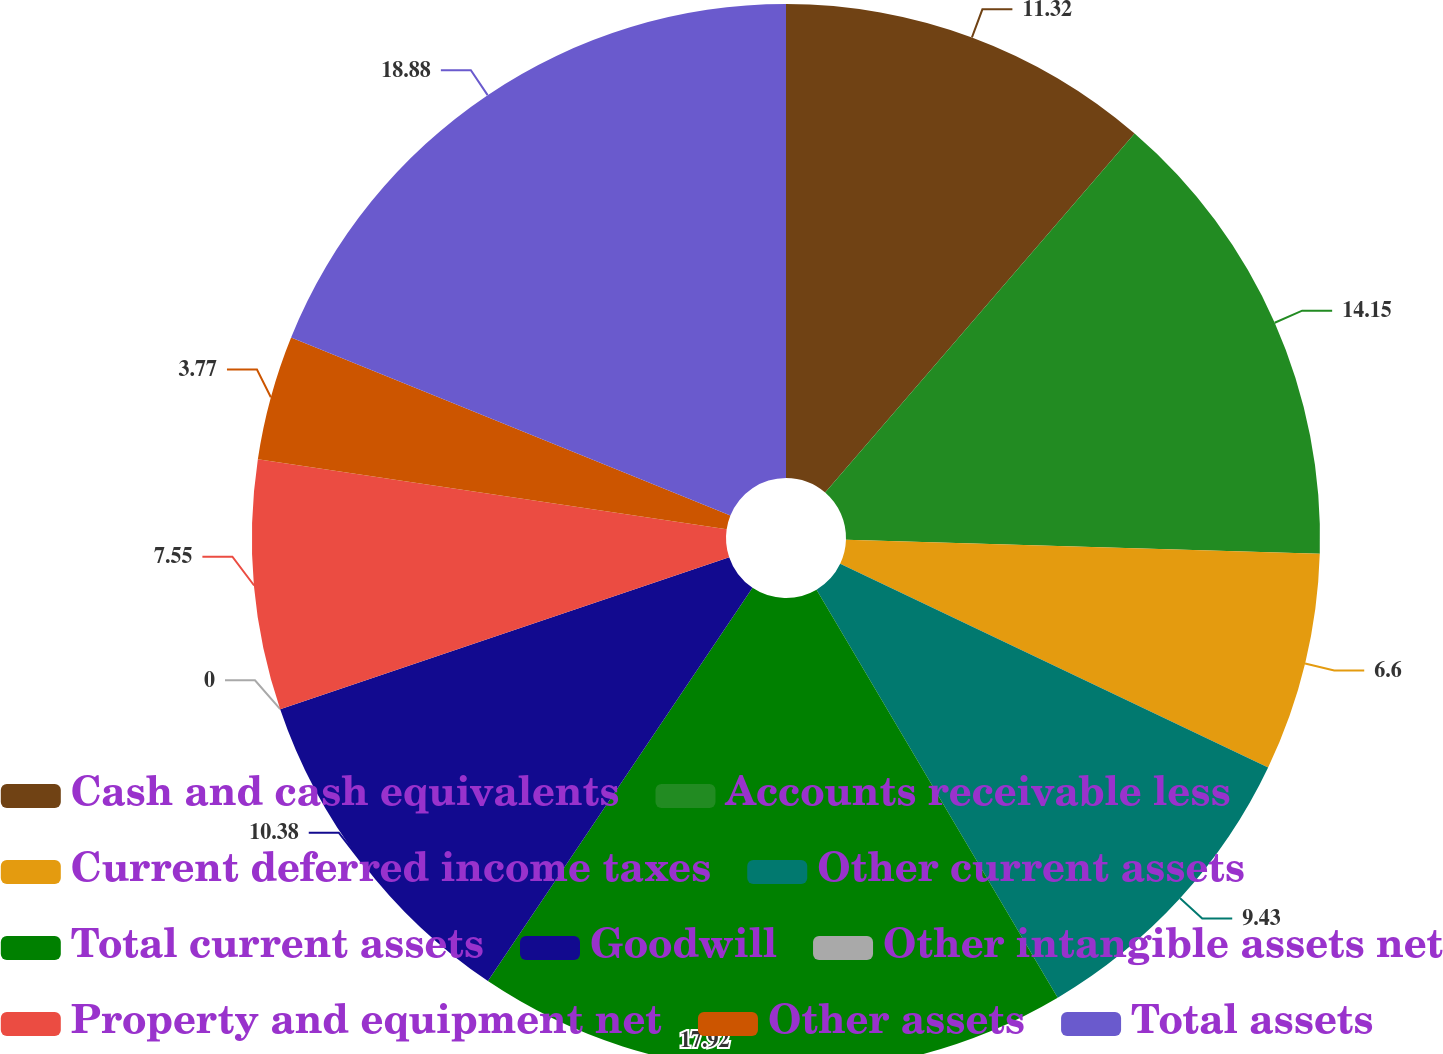Convert chart. <chart><loc_0><loc_0><loc_500><loc_500><pie_chart><fcel>Cash and cash equivalents<fcel>Accounts receivable less<fcel>Current deferred income taxes<fcel>Other current assets<fcel>Total current assets<fcel>Goodwill<fcel>Other intangible assets net<fcel>Property and equipment net<fcel>Other assets<fcel>Total assets<nl><fcel>11.32%<fcel>14.15%<fcel>6.6%<fcel>9.43%<fcel>17.92%<fcel>10.38%<fcel>0.0%<fcel>7.55%<fcel>3.77%<fcel>18.87%<nl></chart> 